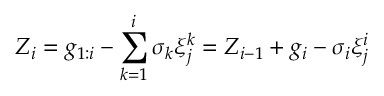<formula> <loc_0><loc_0><loc_500><loc_500>Z _ { i } = g _ { 1 \colon i } - \sum _ { k = 1 } ^ { i } { \sigma _ { k } \xi _ { j } ^ { k } } = Z _ { i - 1 } + g _ { i } - \sigma _ { i } \xi _ { j } ^ { i }</formula> 